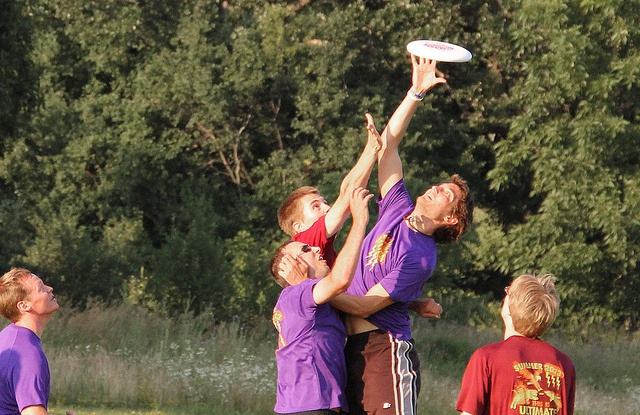Describe the objects in this image and their specific colors. I can see people in black, brown, beige, and maroon tones, people in black, tan, and violet tones, people in black, red, brown, tan, and maroon tones, people in black, violet, brown, and purple tones, and frisbee in black, white, darkgray, pink, and gray tones in this image. 